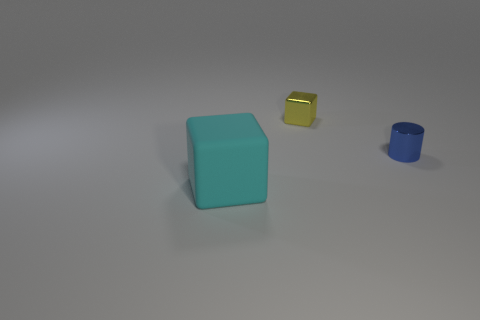Is there any other thing that is the same size as the matte thing?
Provide a short and direct response. No. There is a yellow metal block; is it the same size as the cube that is in front of the small yellow metal block?
Make the answer very short. No. What is the shape of the large cyan object that is in front of the small block?
Keep it short and to the point. Cube. Is there a yellow cube in front of the object that is on the left side of the tiny thing that is behind the tiny blue shiny cylinder?
Your response must be concise. No. What material is the small yellow thing that is the same shape as the cyan rubber thing?
Offer a terse response. Metal. Is there any other thing that is made of the same material as the tiny cylinder?
Your response must be concise. Yes. What number of balls are yellow metallic things or blue shiny things?
Your response must be concise. 0. There is a block behind the cyan rubber thing; is its size the same as the cyan cube in front of the tiny cylinder?
Give a very brief answer. No. The block behind the big rubber block in front of the metal block is made of what material?
Give a very brief answer. Metal. Are there fewer big cubes that are behind the yellow thing than blue things?
Offer a very short reply. Yes. 